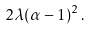<formula> <loc_0><loc_0><loc_500><loc_500>2 \lambda ( \alpha - 1 ) ^ { 2 } \, .</formula> 